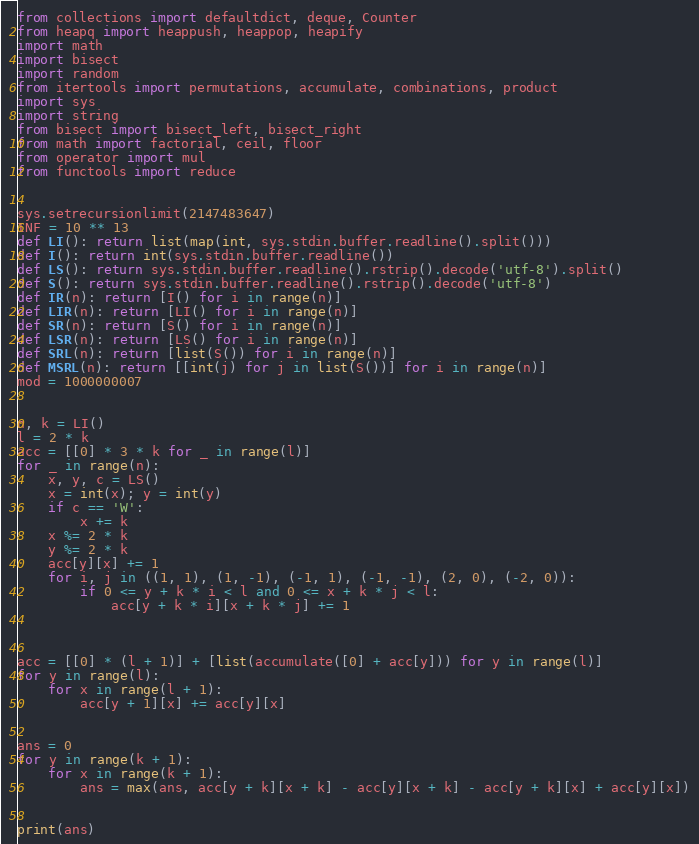<code> <loc_0><loc_0><loc_500><loc_500><_Python_>from collections import defaultdict, deque, Counter
from heapq import heappush, heappop, heapify
import math
import bisect
import random
from itertools import permutations, accumulate, combinations, product
import sys
import string
from bisect import bisect_left, bisect_right
from math import factorial, ceil, floor
from operator import mul
from functools import reduce


sys.setrecursionlimit(2147483647)
INF = 10 ** 13
def LI(): return list(map(int, sys.stdin.buffer.readline().split()))
def I(): return int(sys.stdin.buffer.readline())
def LS(): return sys.stdin.buffer.readline().rstrip().decode('utf-8').split()
def S(): return sys.stdin.buffer.readline().rstrip().decode('utf-8')
def IR(n): return [I() for i in range(n)]
def LIR(n): return [LI() for i in range(n)]
def SR(n): return [S() for i in range(n)]
def LSR(n): return [LS() for i in range(n)]
def SRL(n): return [list(S()) for i in range(n)]
def MSRL(n): return [[int(j) for j in list(S())] for i in range(n)]
mod = 1000000007


n, k = LI()
l = 2 * k
acc = [[0] * 3 * k for _ in range(l)]
for _ in range(n):
    x, y, c = LS()
    x = int(x); y = int(y)
    if c == 'W':
        x += k
    x %= 2 * k
    y %= 2 * k
    acc[y][x] += 1
    for i, j in ((1, 1), (1, -1), (-1, 1), (-1, -1), (2, 0), (-2, 0)):
        if 0 <= y + k * i < l and 0 <= x + k * j < l:
            acc[y + k * i][x + k * j] += 1



acc = [[0] * (l + 1)] + [list(accumulate([0] + acc[y])) for y in range(l)]
for y in range(l):
    for x in range(l + 1):
        acc[y + 1][x] += acc[y][x]


ans = 0
for y in range(k + 1):
    for x in range(k + 1):
        ans = max(ans, acc[y + k][x + k] - acc[y][x + k] - acc[y + k][x] + acc[y][x])


print(ans)</code> 